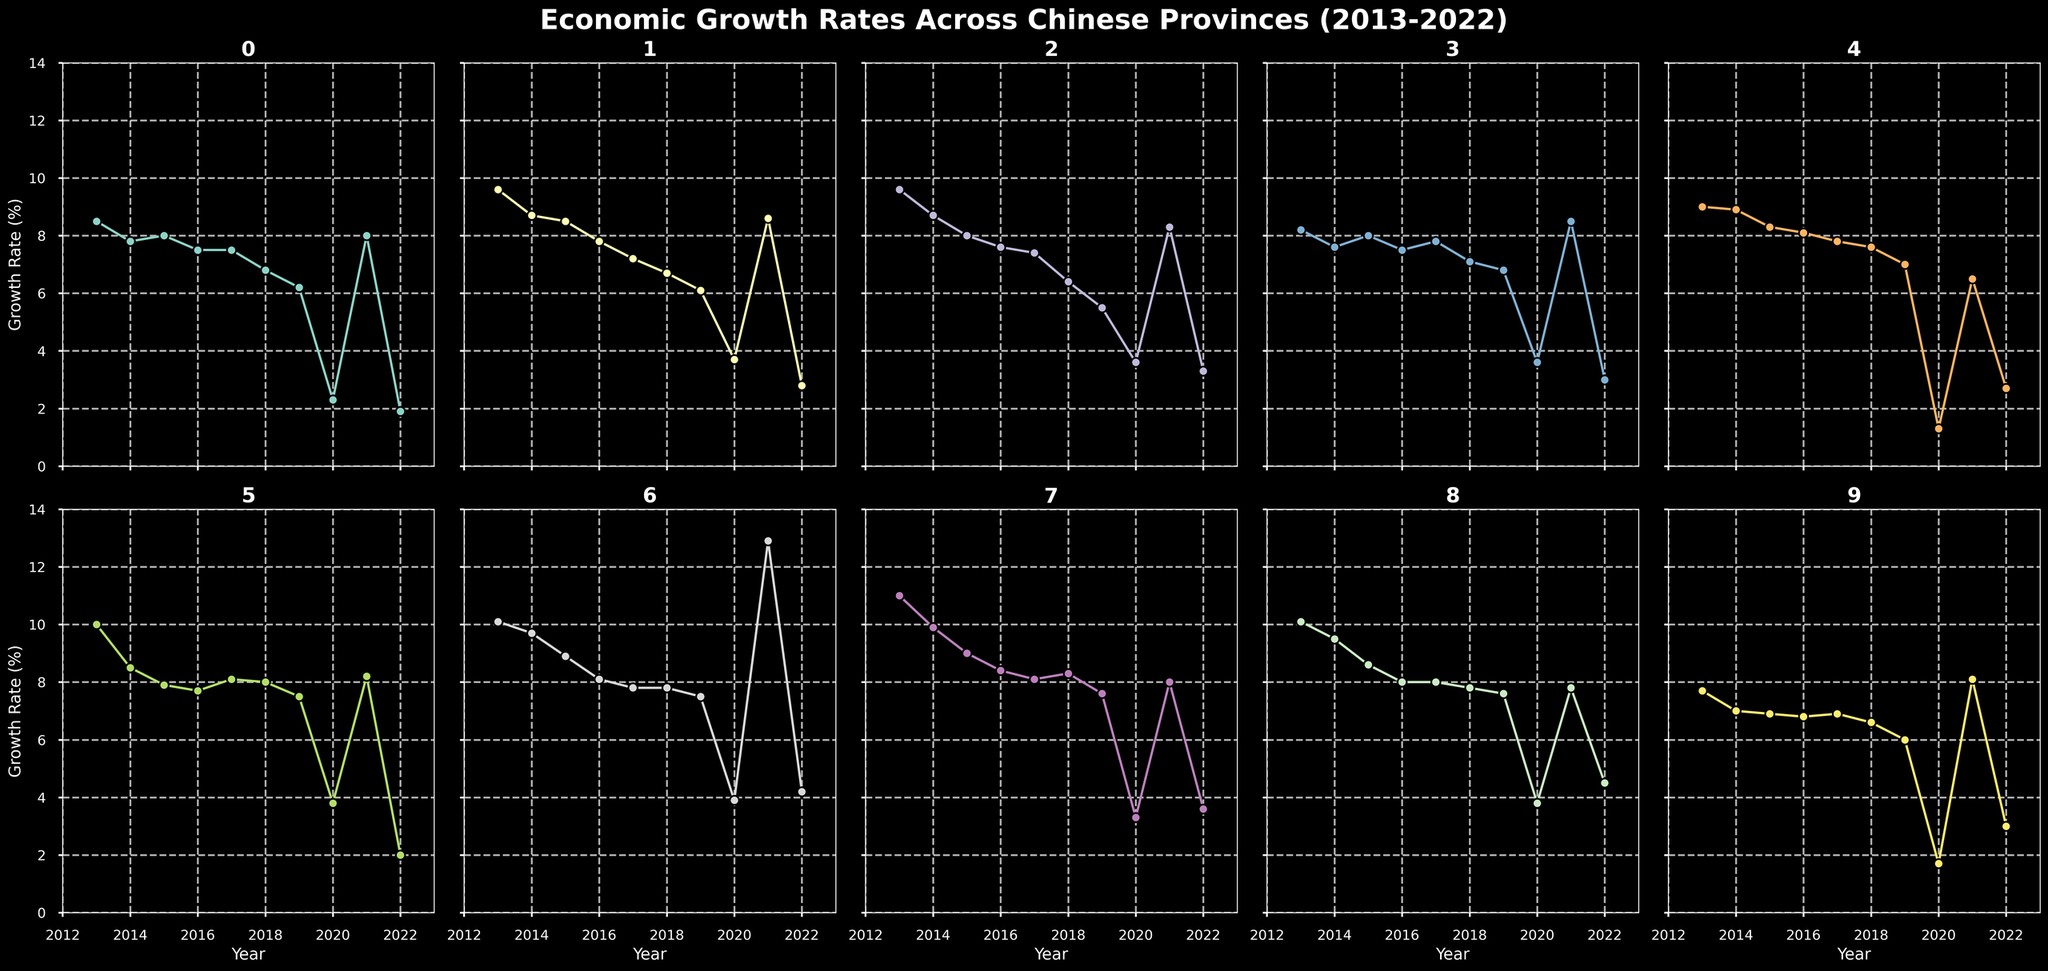How does the economic growth rate of Guangdong in 2017 compare to its growth rate in 2021? To compare the economic growth rates, we look at the specific points for Guangdong in the years 2017 and 2021. In 2017, the growth rate is 7.5%. In 2021, it is 8.0%. Therefore, Guangdong's economic growth rate increased in 2021 compared to 2017.
Answer: 8.0% in 2021 compared to 7.5% in 2017 Among Jiangsu, Shandong, and Zhejiang, which province experienced the highest growth rate in 2022? To determine which province among Jiangsu, Shandong, and Zhejiang experienced the highest growth rate in 2022, we compare their values. Jiangsu has 2.8%, Shandong has 3.3%, and Zhejiang has 3.0%. Hence, Shandong had the highest growth rate in 2022.
Answer: Shandong What is the average economic growth rate of Hubei from 2013 to 2016? To find the average growth rate, we add the rates from 2013 to 2016 and then divide by the number of years. The rates are 10.1, 9.7, 8.9, and 8.1. Sum = 10.1 + 9.7 + 8.9 + 8.1 = 36.8. Average = 36.8 / 4 = 9.2.
Answer: 9.2% Which province had the lowest economic growth rate in 2020? To find the lowest growth rate in 2020, we compare all the values for that year. The rates are: Guangdong 2.3%, Jiangsu 3.7%, Shandong  3.6%, Zhejiang 3.6%, Henan 1.3%, Sichuan 3.8%, Hubei 3.9%, Fujian 3.3%, Hunan 3.8%, Shanghai 1.7%. Henan's rate of 1.3% is the lowest.
Answer: Henan How did Hunan's economic growth rate trend from 2013 to 2022? We look at Hunan's yearly growth rates: 10.1, 9.5, 8.6, 8.0, 8.0, 7.8, 7.6, 3.8, 7.8, 4.5. The trend shows a general decline from 2013 (10.1%) to 2020 (3.8%) with a slight recovery in 2021 (7.8%) and 2022 (4.5%).
Answer: Generally declining with slight recovery What is the difference in economic growth rates between Sichuan in 2013 and its average over the decade? First, we find Sichuan's growth rate in 2013, which is 10.0%. To determine the average growth rate over ten years (2013-2022), we sum the rates and divide by 10. The rates are: 10.0, 8.5, 7.9, 7.7, 8.1, 8.0, 7.5, 3.8, 8.2, 2.0. Sum = 72.7. Average = 72.7 / 10 = 7.27%. The difference = 10.0 - 7.27 = 2.73%.
Answer: 2.73% Which province showed the most significant growth rate increase from 2020 to 2021? To find the most significant increase, we compare the growth rates of all provinces in 2020 and 2021 and find the one with the highest difference. Hubei had 3.9% in 2020 and 12.9% in 2021. Increase = 12.9 - 3.9 = 9.0%, which is the highest.
Answer: Hubei Identify the year with the highest economic growth rate for Fujian province. We compare Fujian's growth rates across all years: 11.0, 9.9, 9.0, 8.4, 8.1, 8.3, 7.6, 3.3, 8.0, 3.6. The highest rate is 11.0%, which occurred in 2013.
Answer: 2013 